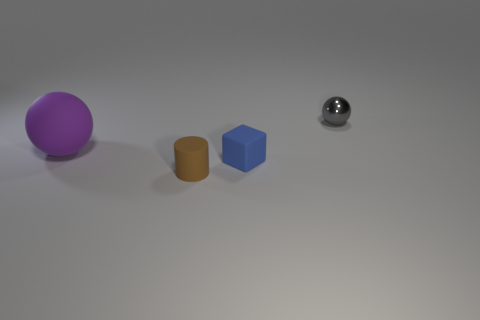Are there any small brown cylinders?
Provide a short and direct response. Yes. Is the blue rubber thing the same shape as the metallic thing?
Give a very brief answer. No. There is a sphere in front of the sphere on the right side of the tiny brown cylinder; what number of tiny brown matte things are to the right of it?
Ensure brevity in your answer.  1. What is the small object that is both in front of the large ball and behind the rubber cylinder made of?
Make the answer very short. Rubber. What color is the small object that is both behind the tiny brown thing and left of the small ball?
Ensure brevity in your answer.  Blue. Is there any other thing of the same color as the cylinder?
Ensure brevity in your answer.  No. The small thing behind the sphere that is left of the ball that is to the right of the brown matte thing is what shape?
Keep it short and to the point. Sphere. There is a large matte object that is the same shape as the small gray metallic thing; what color is it?
Keep it short and to the point. Purple. What is the color of the thing that is left of the tiny matte thing to the left of the tiny blue rubber object?
Give a very brief answer. Purple. What is the size of the other thing that is the same shape as the gray thing?
Offer a very short reply. Large. 